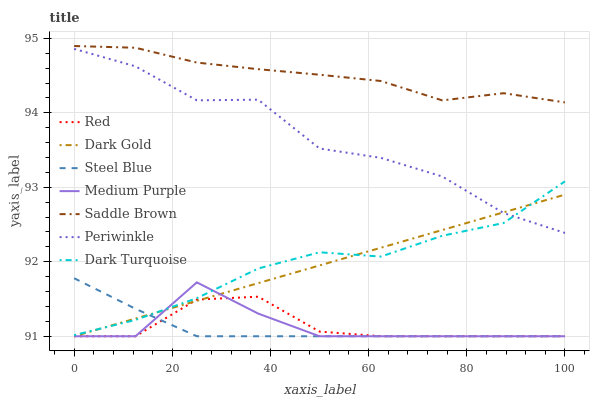Does Steel Blue have the minimum area under the curve?
Answer yes or no. Yes. Does Saddle Brown have the maximum area under the curve?
Answer yes or no. Yes. Does Dark Turquoise have the minimum area under the curve?
Answer yes or no. No. Does Dark Turquoise have the maximum area under the curve?
Answer yes or no. No. Is Dark Gold the smoothest?
Answer yes or no. Yes. Is Periwinkle the roughest?
Answer yes or no. Yes. Is Dark Turquoise the smoothest?
Answer yes or no. No. Is Dark Turquoise the roughest?
Answer yes or no. No. Does Dark Gold have the lowest value?
Answer yes or no. Yes. Does Dark Turquoise have the lowest value?
Answer yes or no. No. Does Saddle Brown have the highest value?
Answer yes or no. Yes. Does Dark Turquoise have the highest value?
Answer yes or no. No. Is Dark Turquoise less than Saddle Brown?
Answer yes or no. Yes. Is Saddle Brown greater than Dark Gold?
Answer yes or no. Yes. Does Dark Gold intersect Medium Purple?
Answer yes or no. Yes. Is Dark Gold less than Medium Purple?
Answer yes or no. No. Is Dark Gold greater than Medium Purple?
Answer yes or no. No. Does Dark Turquoise intersect Saddle Brown?
Answer yes or no. No. 